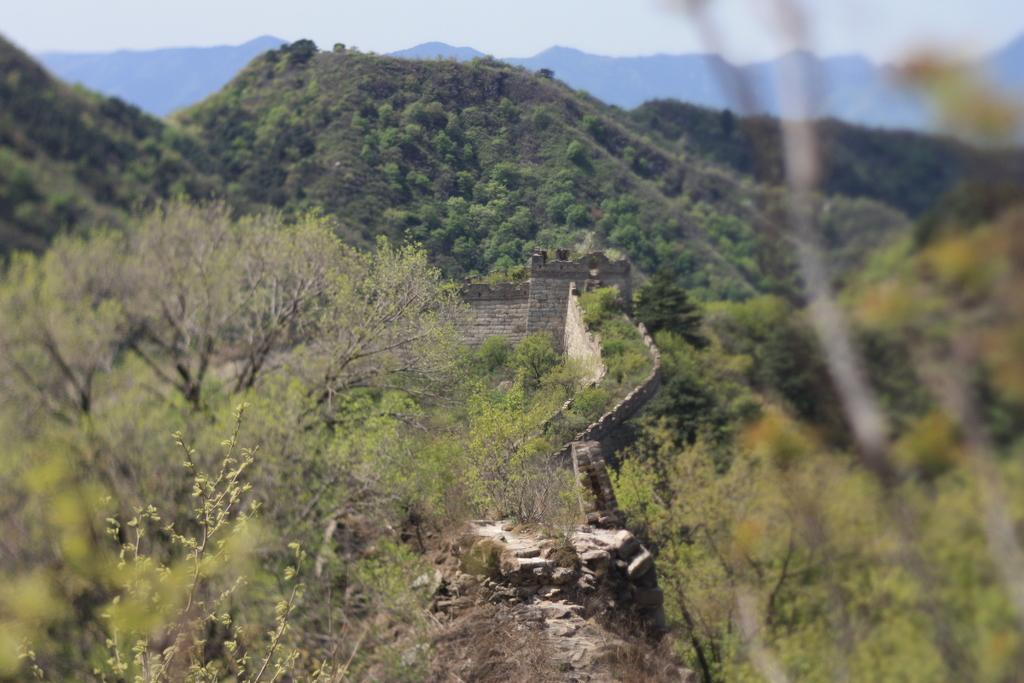What type of vegetation can be seen in the image? There are trees in the image. What natural feature is visible in the background of the image? There is a mountain in the background of the image. What else can be seen in the background of the image? The sky is visible in the background of the image. What type of iron bell can be heard ringing in the image? There is no iron bell present in the image, and therefore no sound can be heard. 